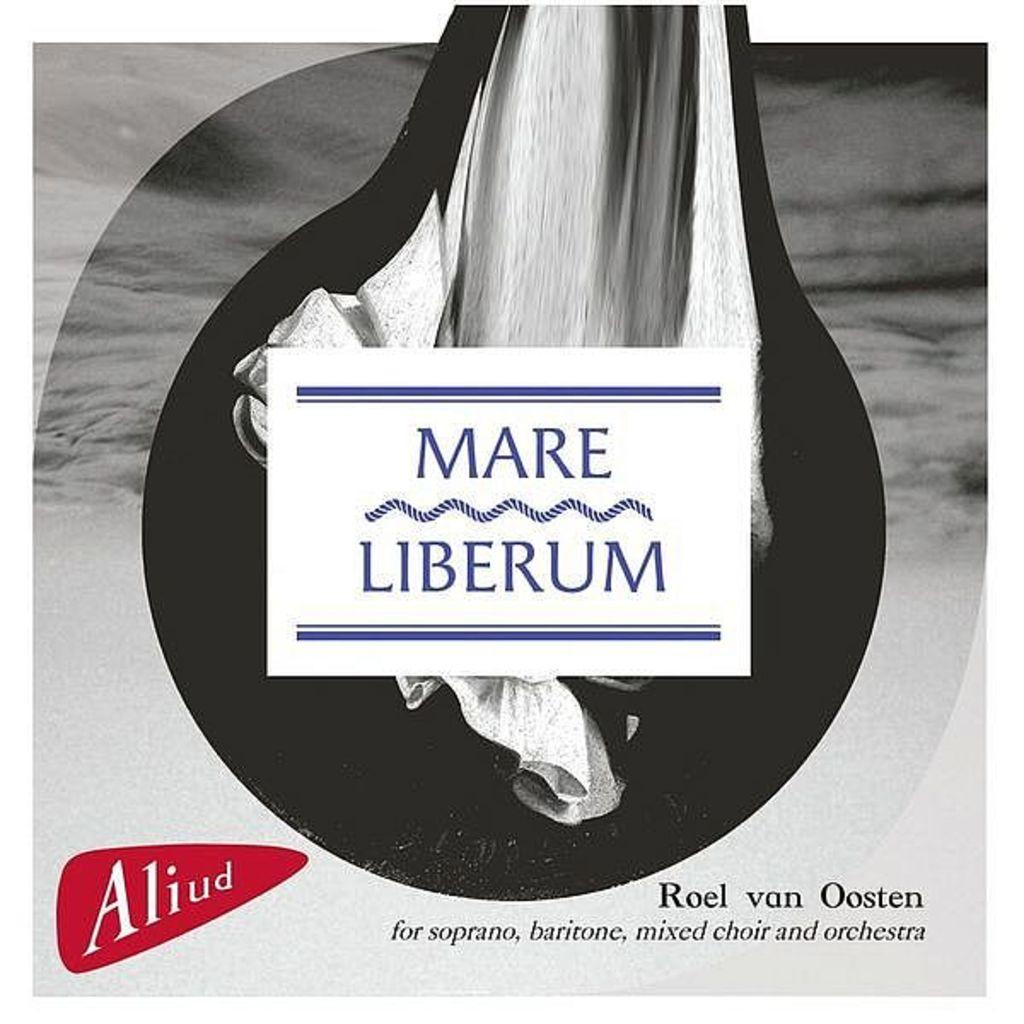What can be seen hanging on the wall in the image? There is a poster in the image. What is shown on the poster? There is an object depicted on the poster. Are there any words or letters on the poster? Yes, there is text printed on the poster. How many bears are visible in the image? There are no bears present in the image. What type of lead is being used by the police officer in the image? There is no police officer or lead present in the image. 